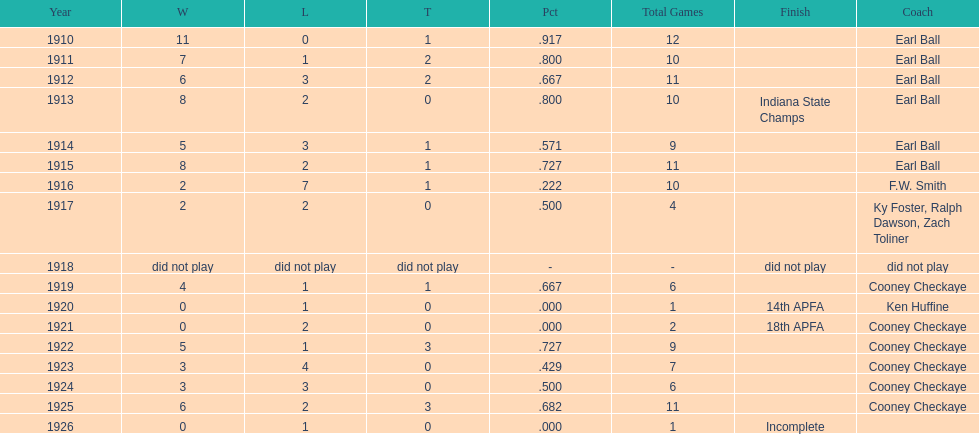In what year did the muncie flyers have an undefeated record? 1910. 